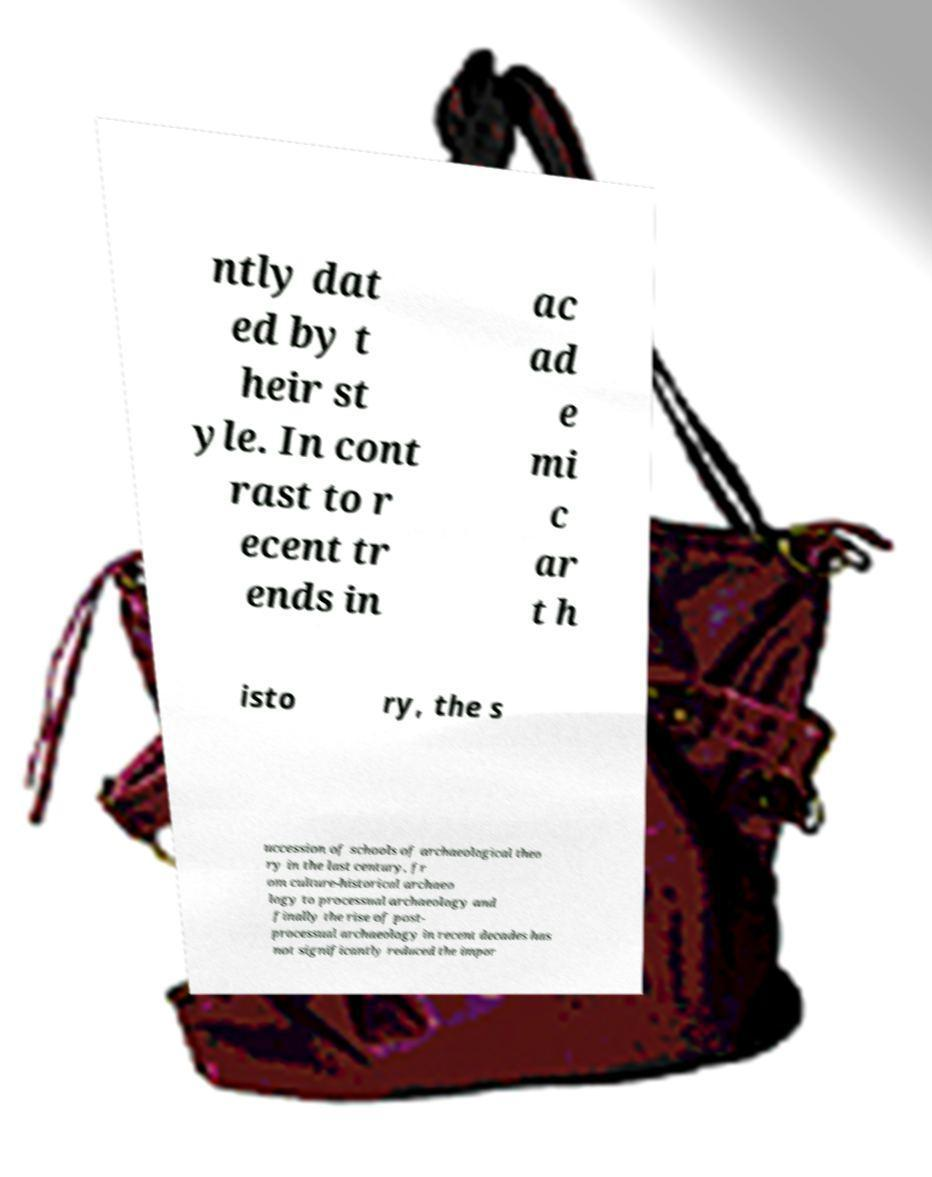Please identify and transcribe the text found in this image. ntly dat ed by t heir st yle. In cont rast to r ecent tr ends in ac ad e mi c ar t h isto ry, the s uccession of schools of archaeological theo ry in the last century, fr om culture-historical archaeo logy to processual archaeology and finally the rise of post- processual archaeology in recent decades has not significantly reduced the impor 